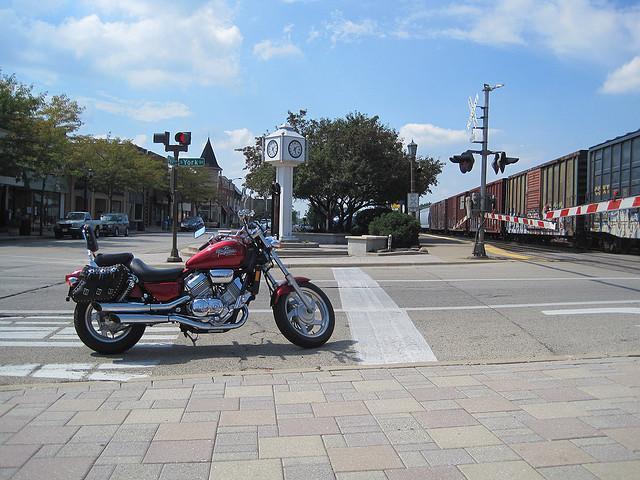How many people can safely ride this motorcycle?
Give a very brief answer. 2. How many giraffes are looking toward the camera?
Give a very brief answer. 0. 